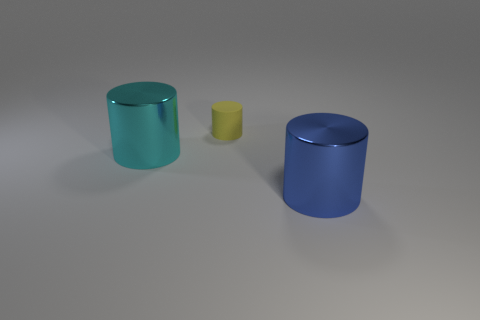Add 1 tiny red metallic objects. How many objects exist? 4 Add 2 tiny matte things. How many tiny matte things exist? 3 Subtract 0 blue balls. How many objects are left? 3 Subtract all large purple rubber blocks. Subtract all matte cylinders. How many objects are left? 2 Add 2 blue cylinders. How many blue cylinders are left? 3 